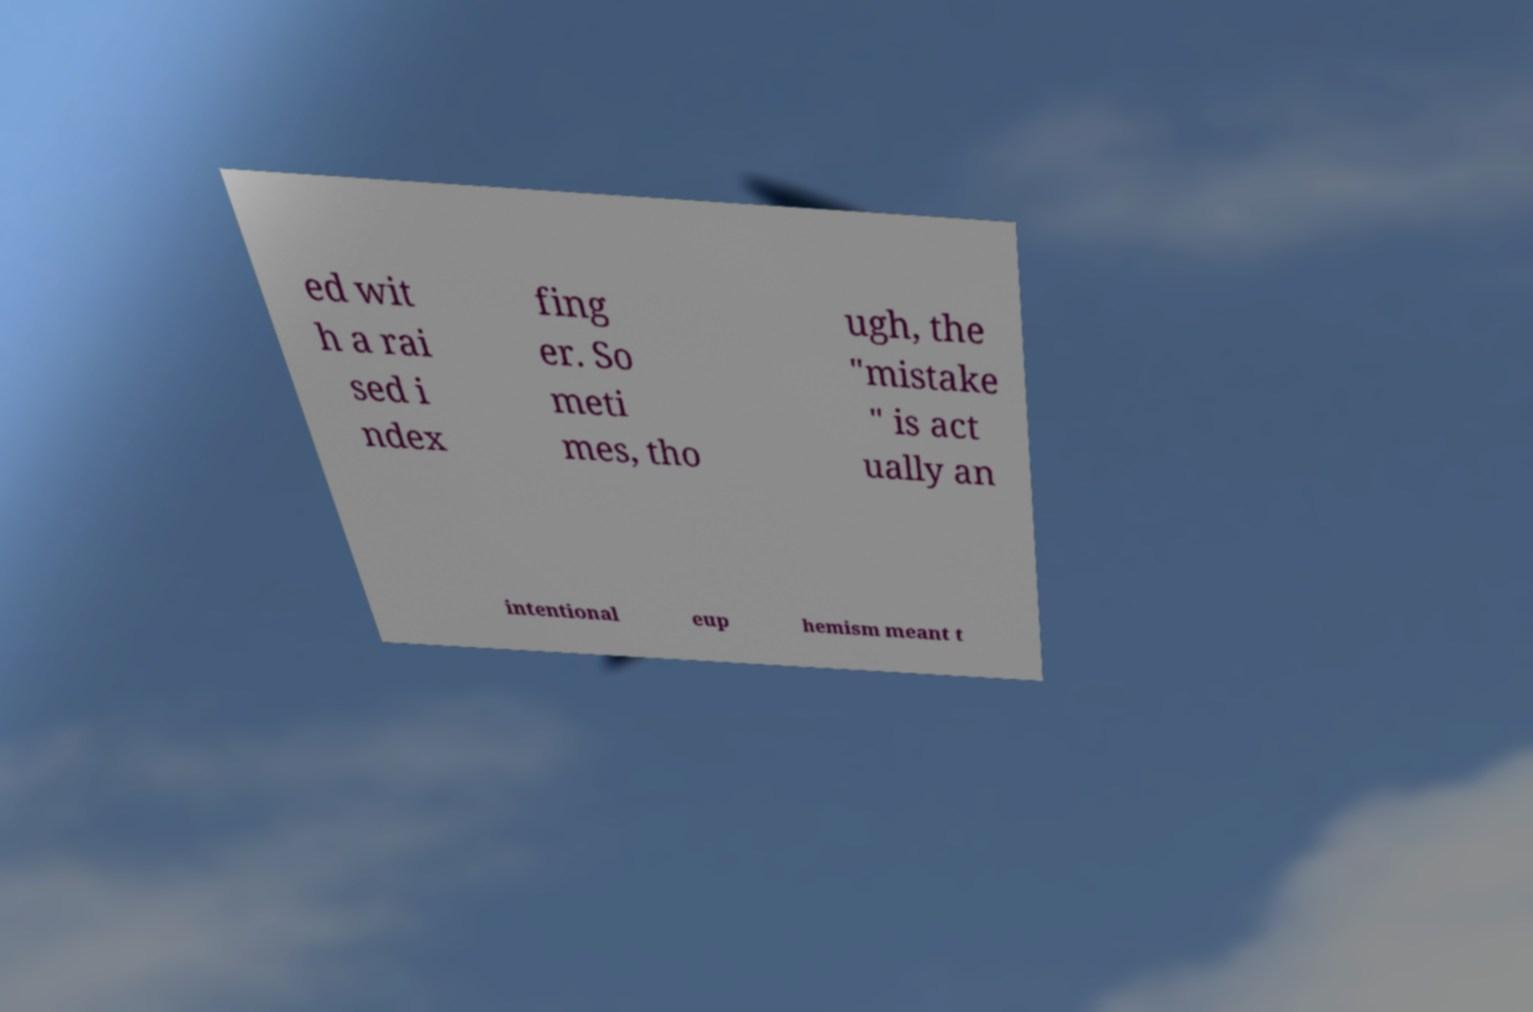Could you assist in decoding the text presented in this image and type it out clearly? ed wit h a rai sed i ndex fing er. So meti mes, tho ugh, the "mistake " is act ually an intentional eup hemism meant t 